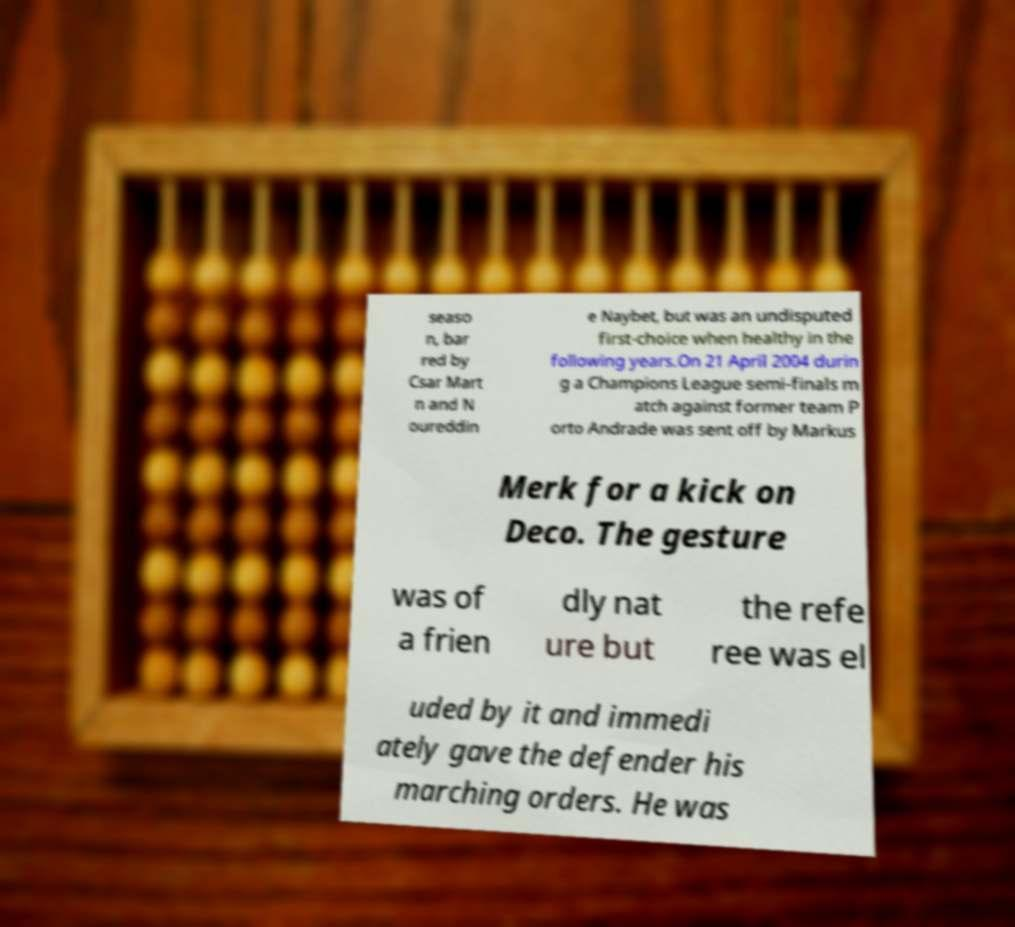Please read and relay the text visible in this image. What does it say? seaso n, bar red by Csar Mart n and N oureddin e Naybet, but was an undisputed first-choice when healthy in the following years.On 21 April 2004 durin g a Champions League semi-finals m atch against former team P orto Andrade was sent off by Markus Merk for a kick on Deco. The gesture was of a frien dly nat ure but the refe ree was el uded by it and immedi ately gave the defender his marching orders. He was 